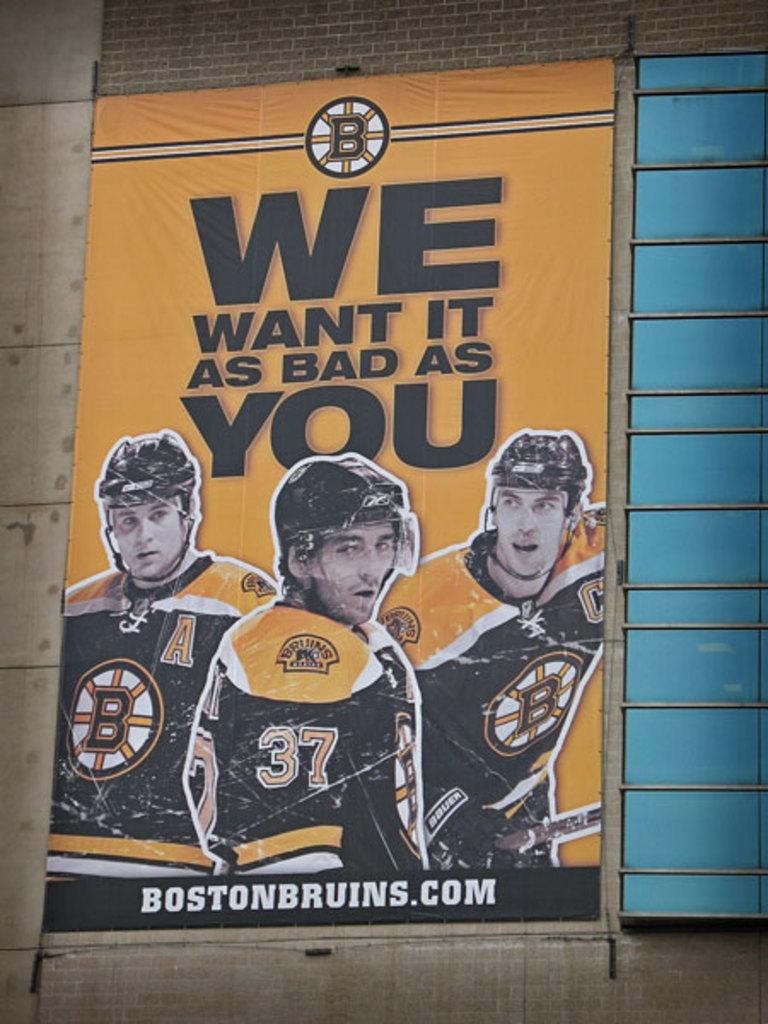Provide a one-sentence caption for the provided image. Hockey poster telling people we want is as bad as you. 